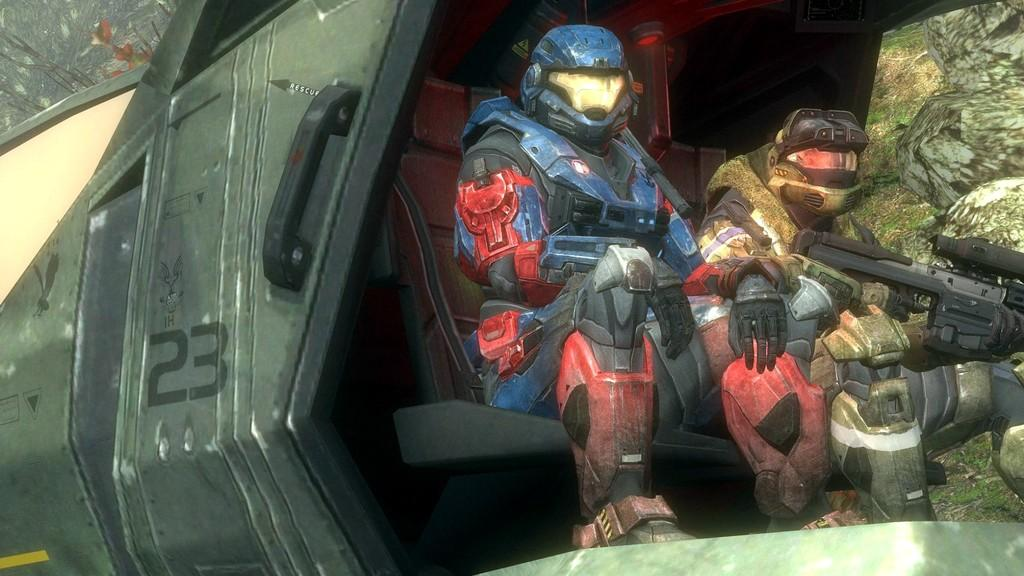What type of image is being described? The image is animated. What characters are present in the image? There are two robots in the image. What are the robots doing in the image? The robots are sitting in a vehicle. What type of education system do the robots attend in the image? There is no indication of an education system or any educational activity in the image, as it features two robots sitting in a vehicle. 